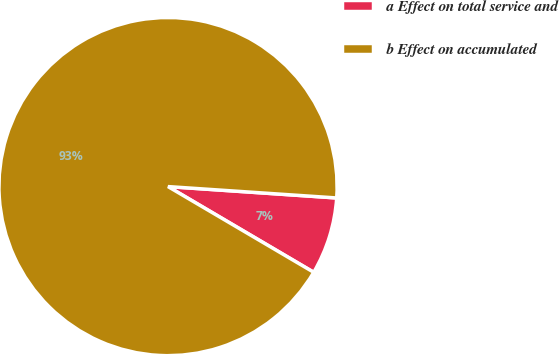<chart> <loc_0><loc_0><loc_500><loc_500><pie_chart><fcel>a Effect on total service and<fcel>b Effect on accumulated<nl><fcel>7.39%<fcel>92.61%<nl></chart> 